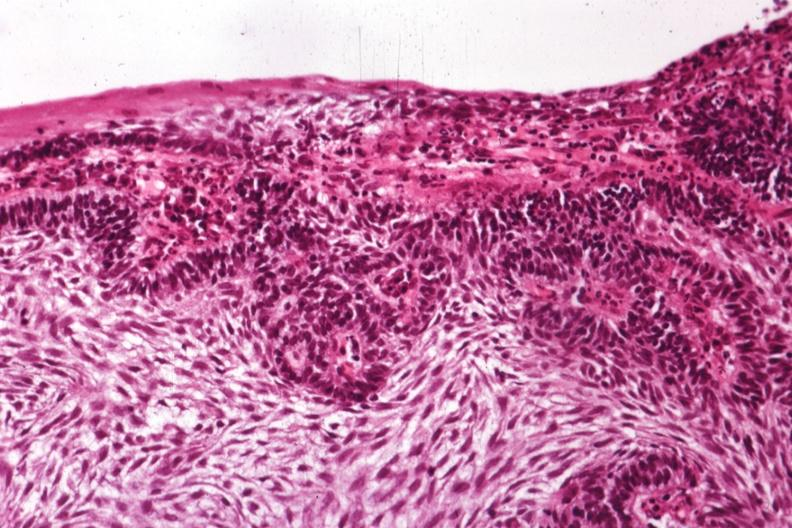what is present?
Answer the question using a single word or phrase. Bone, mandible 